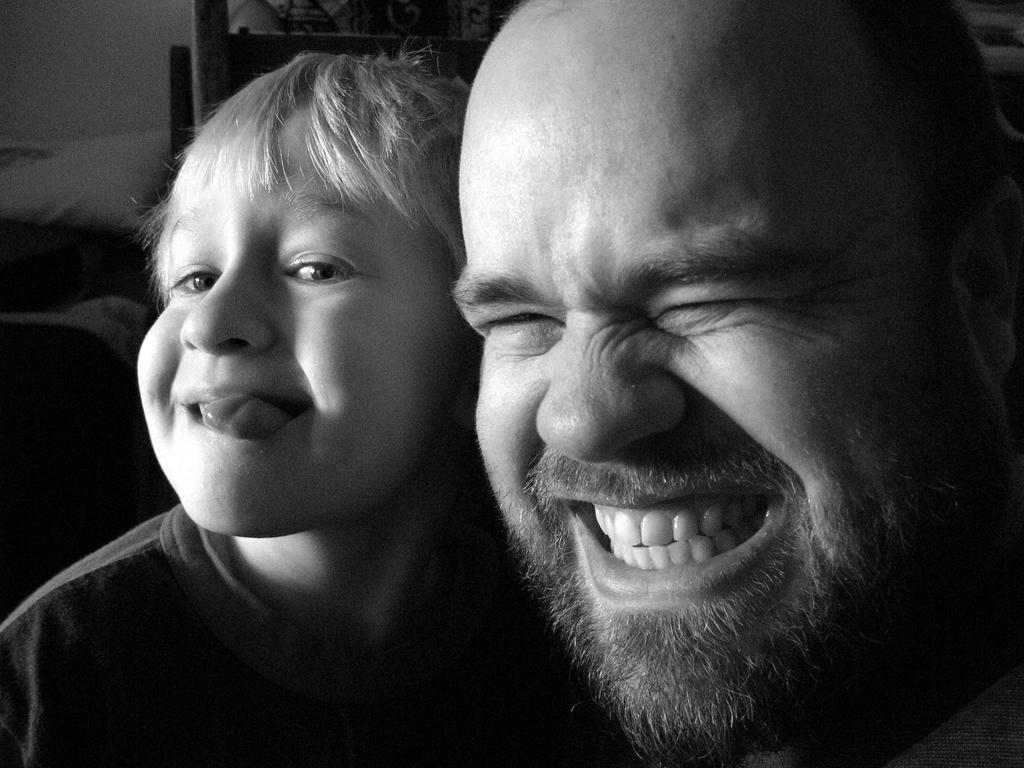What is the color scheme of the image? The image is black and white. Who is present in the image? There is a man and a child in the image. What is the man doing in the image? The man is smiling in the image. What is the child doing in the image? The child is sticking their tongue out in the image. How many balls can be seen on the scale in the image? There are no balls or scales present in the image. What type of houses are visible in the background of the image? There are no houses visible in the image; it is a black and white image featuring a man and a child. 